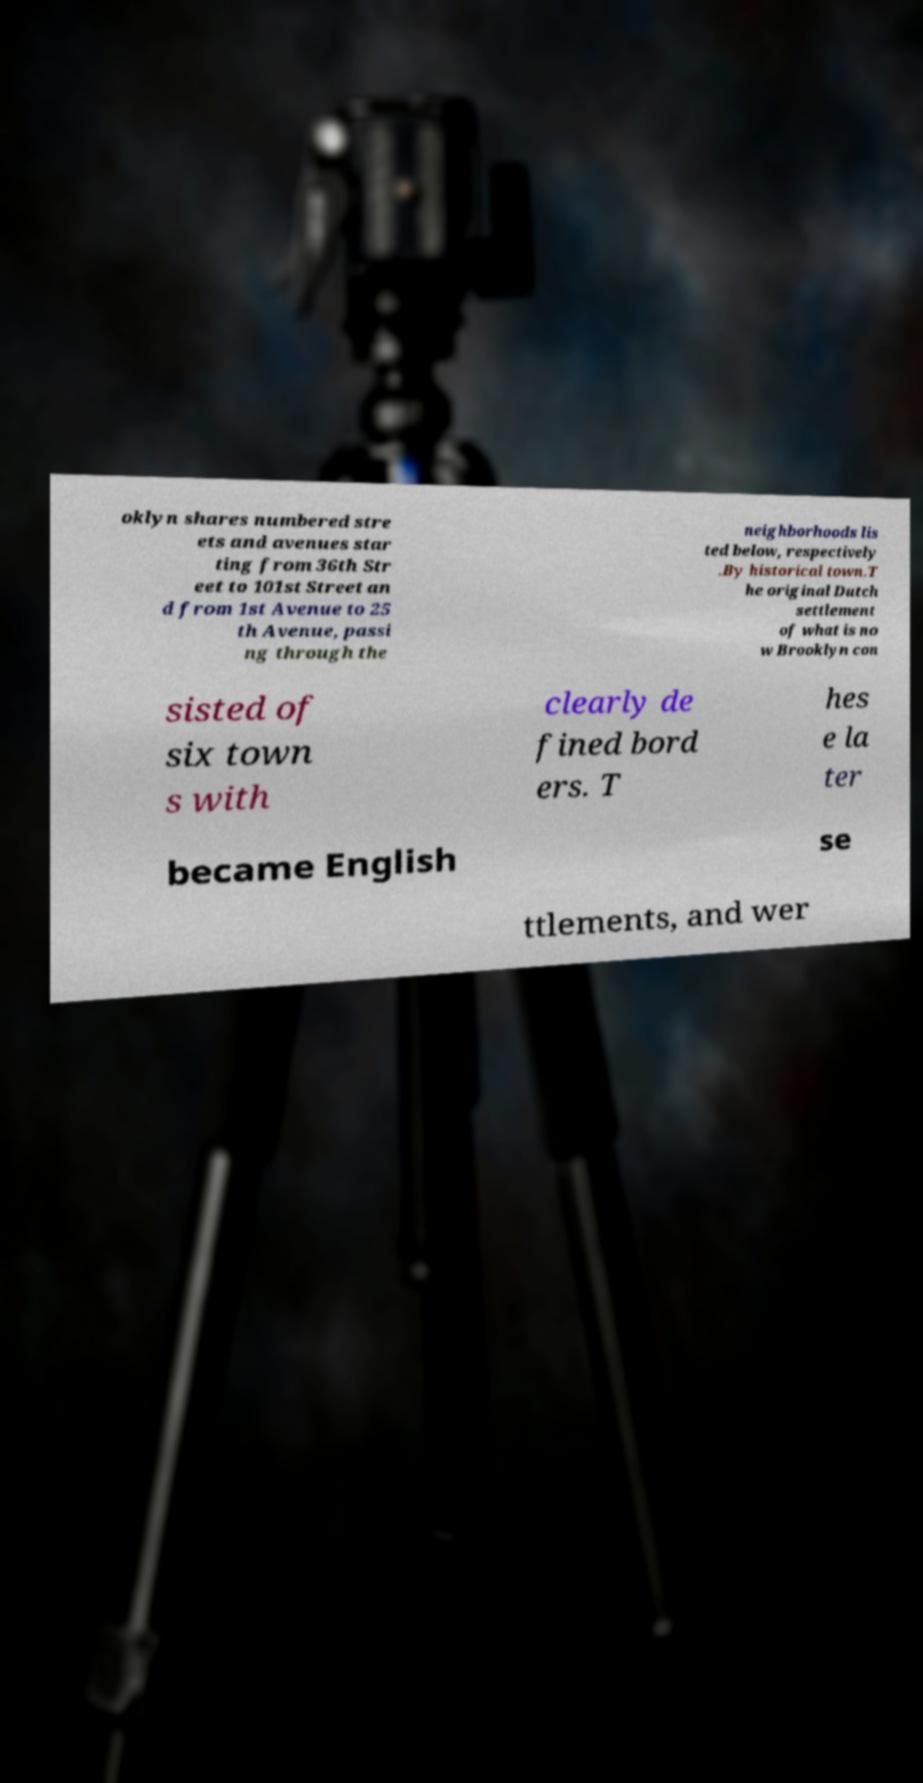Please identify and transcribe the text found in this image. oklyn shares numbered stre ets and avenues star ting from 36th Str eet to 101st Street an d from 1st Avenue to 25 th Avenue, passi ng through the neighborhoods lis ted below, respectively .By historical town.T he original Dutch settlement of what is no w Brooklyn con sisted of six town s with clearly de fined bord ers. T hes e la ter became English se ttlements, and wer 